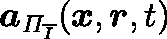Convert formula to latex. <formula><loc_0><loc_0><loc_500><loc_500>a _ { \Pi _ { \overline { I } } } ( x , r , t )</formula> 